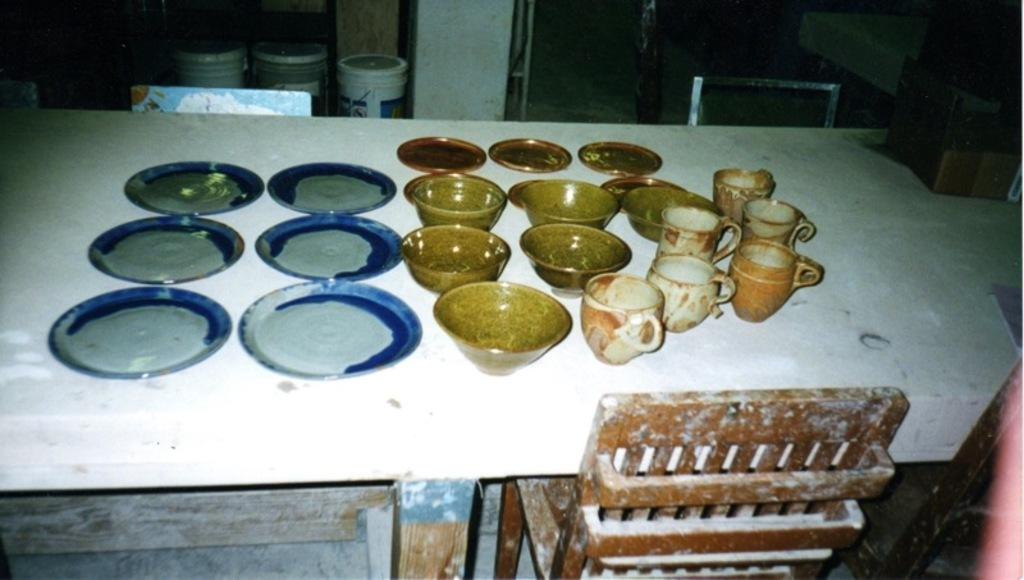What type of tableware can be seen on the table in the image? There are plates, bowls, and cups on the table in the image. What type of furniture is present in the image? There are chairs in the image. What other objects can be seen in the image? There are buckets and a pillar in the image. What part of the room is visible in the image? The floor is visible in the image. How many people are in the group that is wearing caps in the image? There is no group of people wearing caps in the image; the focus is on the tableware, furniture, and other objects. 